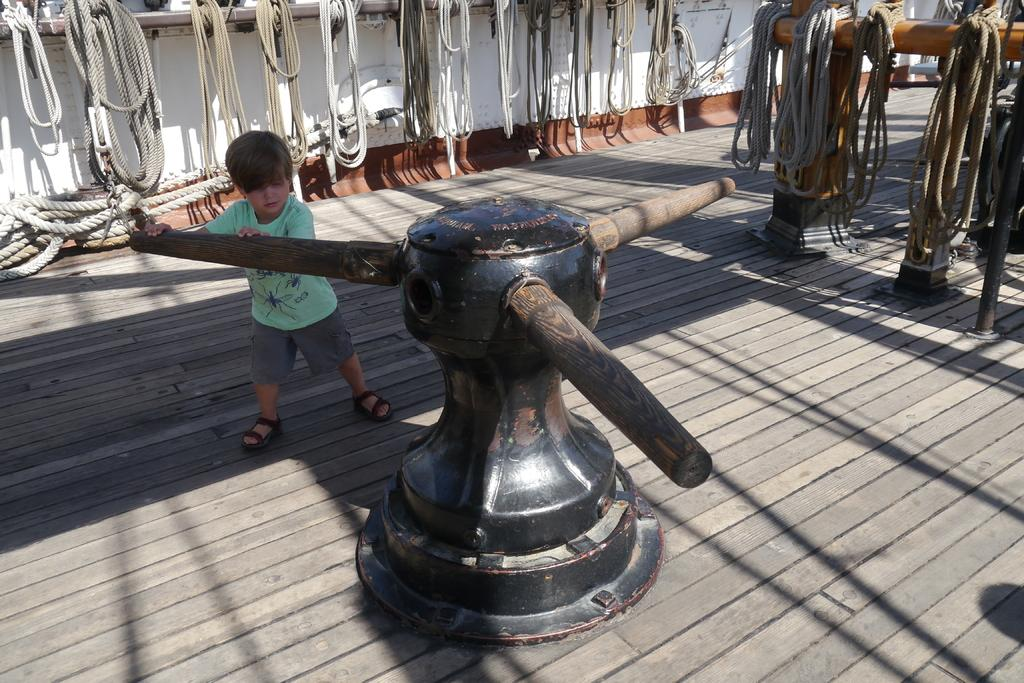Who is the main subject in the image? A: There is a boy in the center of the image. What is the boy holding in the image? The boy is holding a machine. What can be seen in the background of the image? There is a wall, ropes, and rods visible in the background of the image. What is the surface on which the boy is standing? There is a floor at the bottom of the image. What color is the boy's eye in the image? The image does not provide information about the color of the boy's eye. What type of dress is the boy wearing in the image? The image does not show the boy wearing a dress. 